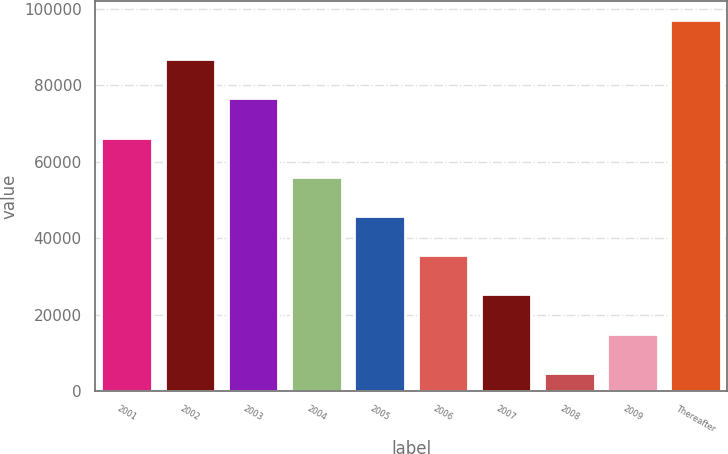Convert chart to OTSL. <chart><loc_0><loc_0><loc_500><loc_500><bar_chart><fcel>2001<fcel>2002<fcel>2003<fcel>2004<fcel>2005<fcel>2006<fcel>2007<fcel>2008<fcel>2009<fcel>Thereafter<nl><fcel>66277.8<fcel>86787.4<fcel>76532.6<fcel>56023<fcel>45768.2<fcel>35513.4<fcel>25258.6<fcel>4749<fcel>15003.8<fcel>97042.2<nl></chart> 